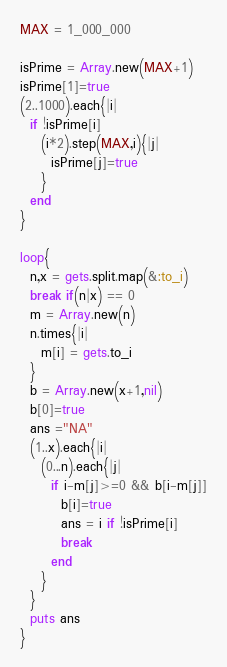Convert code to text. <code><loc_0><loc_0><loc_500><loc_500><_Ruby_>MAX = 1_000_000

isPrime = Array.new(MAX+1)
isPrime[1]=true
(2..1000).each{|i|
  if !isPrime[i]
    (i*2).step(MAX,i){|j|
      isPrime[j]=true
    }
  end
}

loop{
  n,x = gets.split.map(&:to_i)
  break if(n|x) == 0
  m = Array.new(n)
  n.times{|i|
    m[i] = gets.to_i
  }
  b = Array.new(x+1,nil)
  b[0]=true
  ans ="NA"
  (1..x).each{|i|
    (0...n).each{|j|
      if i-m[j]>=0 && b[i-m[j]]
        b[i]=true
        ans = i if !isPrime[i]
        break
      end
    }
  }
  puts ans
}</code> 